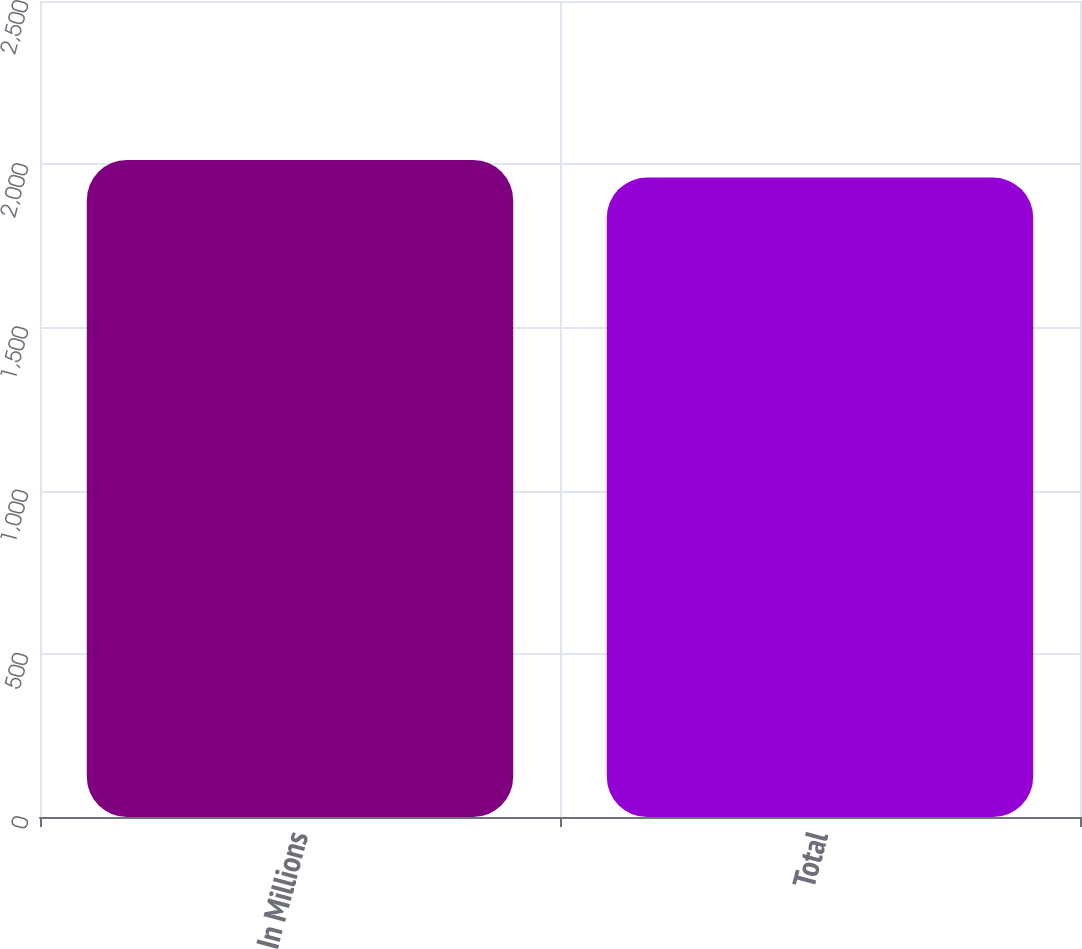<chart> <loc_0><loc_0><loc_500><loc_500><bar_chart><fcel>In Millions<fcel>Total<nl><fcel>2013<fcel>1959<nl></chart> 